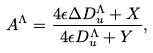Convert formula to latex. <formula><loc_0><loc_0><loc_500><loc_500>A ^ { \Lambda } = \frac { 4 \epsilon \Delta D ^ { \Lambda } _ { u } + X } { 4 \epsilon D ^ { \Lambda } _ { u } + Y } ,</formula> 